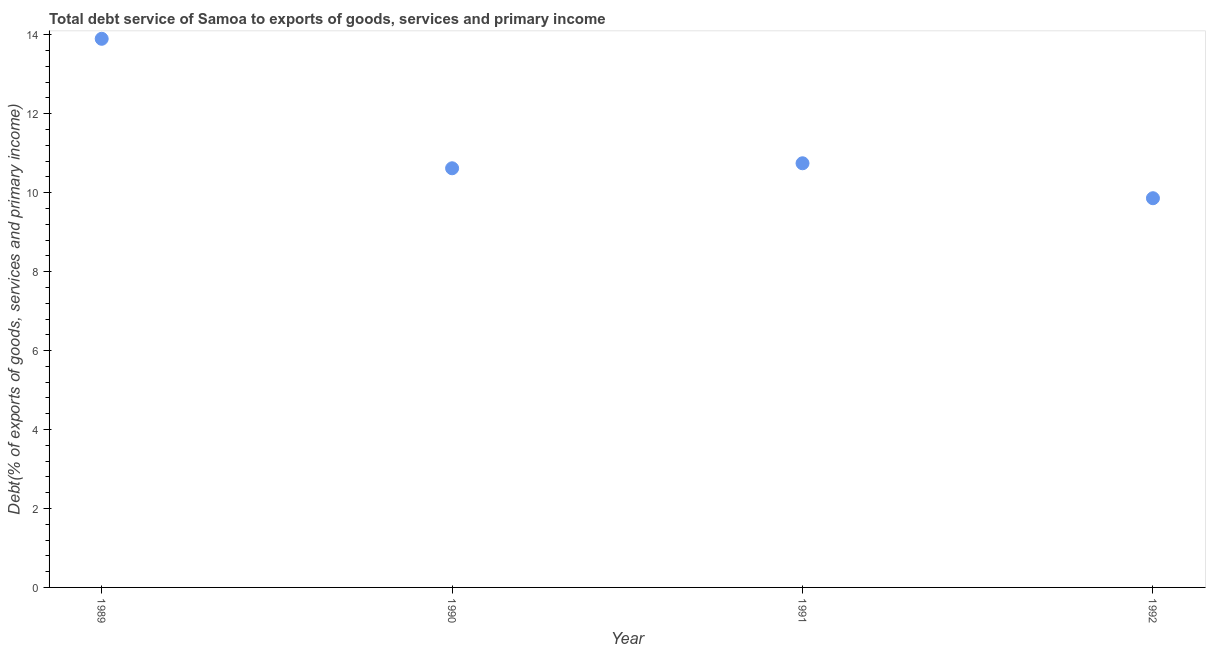What is the total debt service in 1991?
Your response must be concise. 10.75. Across all years, what is the maximum total debt service?
Keep it short and to the point. 13.9. Across all years, what is the minimum total debt service?
Your response must be concise. 9.86. In which year was the total debt service maximum?
Ensure brevity in your answer.  1989. What is the sum of the total debt service?
Your answer should be very brief. 45.13. What is the difference between the total debt service in 1990 and 1992?
Offer a terse response. 0.76. What is the average total debt service per year?
Your answer should be compact. 11.28. What is the median total debt service?
Give a very brief answer. 10.68. In how many years, is the total debt service greater than 10.4 %?
Make the answer very short. 3. What is the ratio of the total debt service in 1991 to that in 1992?
Provide a succinct answer. 1.09. Is the total debt service in 1991 less than that in 1992?
Make the answer very short. No. What is the difference between the highest and the second highest total debt service?
Your response must be concise. 3.15. Is the sum of the total debt service in 1989 and 1992 greater than the maximum total debt service across all years?
Provide a short and direct response. Yes. What is the difference between the highest and the lowest total debt service?
Ensure brevity in your answer.  4.04. In how many years, is the total debt service greater than the average total debt service taken over all years?
Provide a short and direct response. 1. Does the total debt service monotonically increase over the years?
Offer a very short reply. No. How many dotlines are there?
Your answer should be very brief. 1. Are the values on the major ticks of Y-axis written in scientific E-notation?
Keep it short and to the point. No. Does the graph contain any zero values?
Provide a succinct answer. No. Does the graph contain grids?
Provide a succinct answer. No. What is the title of the graph?
Offer a very short reply. Total debt service of Samoa to exports of goods, services and primary income. What is the label or title of the X-axis?
Your response must be concise. Year. What is the label or title of the Y-axis?
Give a very brief answer. Debt(% of exports of goods, services and primary income). What is the Debt(% of exports of goods, services and primary income) in 1989?
Your response must be concise. 13.9. What is the Debt(% of exports of goods, services and primary income) in 1990?
Ensure brevity in your answer.  10.62. What is the Debt(% of exports of goods, services and primary income) in 1991?
Your answer should be very brief. 10.75. What is the Debt(% of exports of goods, services and primary income) in 1992?
Ensure brevity in your answer.  9.86. What is the difference between the Debt(% of exports of goods, services and primary income) in 1989 and 1990?
Provide a succinct answer. 3.28. What is the difference between the Debt(% of exports of goods, services and primary income) in 1989 and 1991?
Your response must be concise. 3.15. What is the difference between the Debt(% of exports of goods, services and primary income) in 1989 and 1992?
Your answer should be compact. 4.04. What is the difference between the Debt(% of exports of goods, services and primary income) in 1990 and 1991?
Keep it short and to the point. -0.13. What is the difference between the Debt(% of exports of goods, services and primary income) in 1990 and 1992?
Give a very brief answer. 0.76. What is the difference between the Debt(% of exports of goods, services and primary income) in 1991 and 1992?
Provide a succinct answer. 0.89. What is the ratio of the Debt(% of exports of goods, services and primary income) in 1989 to that in 1990?
Make the answer very short. 1.31. What is the ratio of the Debt(% of exports of goods, services and primary income) in 1989 to that in 1991?
Offer a terse response. 1.29. What is the ratio of the Debt(% of exports of goods, services and primary income) in 1989 to that in 1992?
Give a very brief answer. 1.41. What is the ratio of the Debt(% of exports of goods, services and primary income) in 1990 to that in 1992?
Your answer should be very brief. 1.08. What is the ratio of the Debt(% of exports of goods, services and primary income) in 1991 to that in 1992?
Your response must be concise. 1.09. 